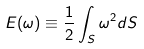Convert formula to latex. <formula><loc_0><loc_0><loc_500><loc_500>E ( \omega ) \equiv \frac { 1 } { 2 } \int _ { S } \omega ^ { 2 } d S</formula> 